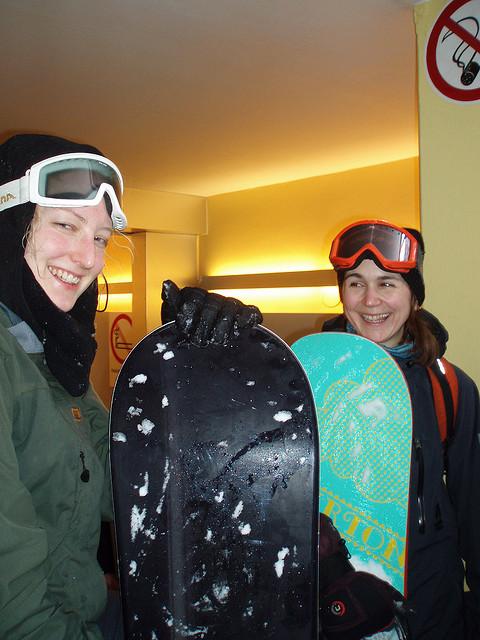How many people are there?
Write a very short answer. 2. Is there a no smoking sign?
Quick response, please. Yes. Is the boards wet?
Give a very brief answer. Yes. 